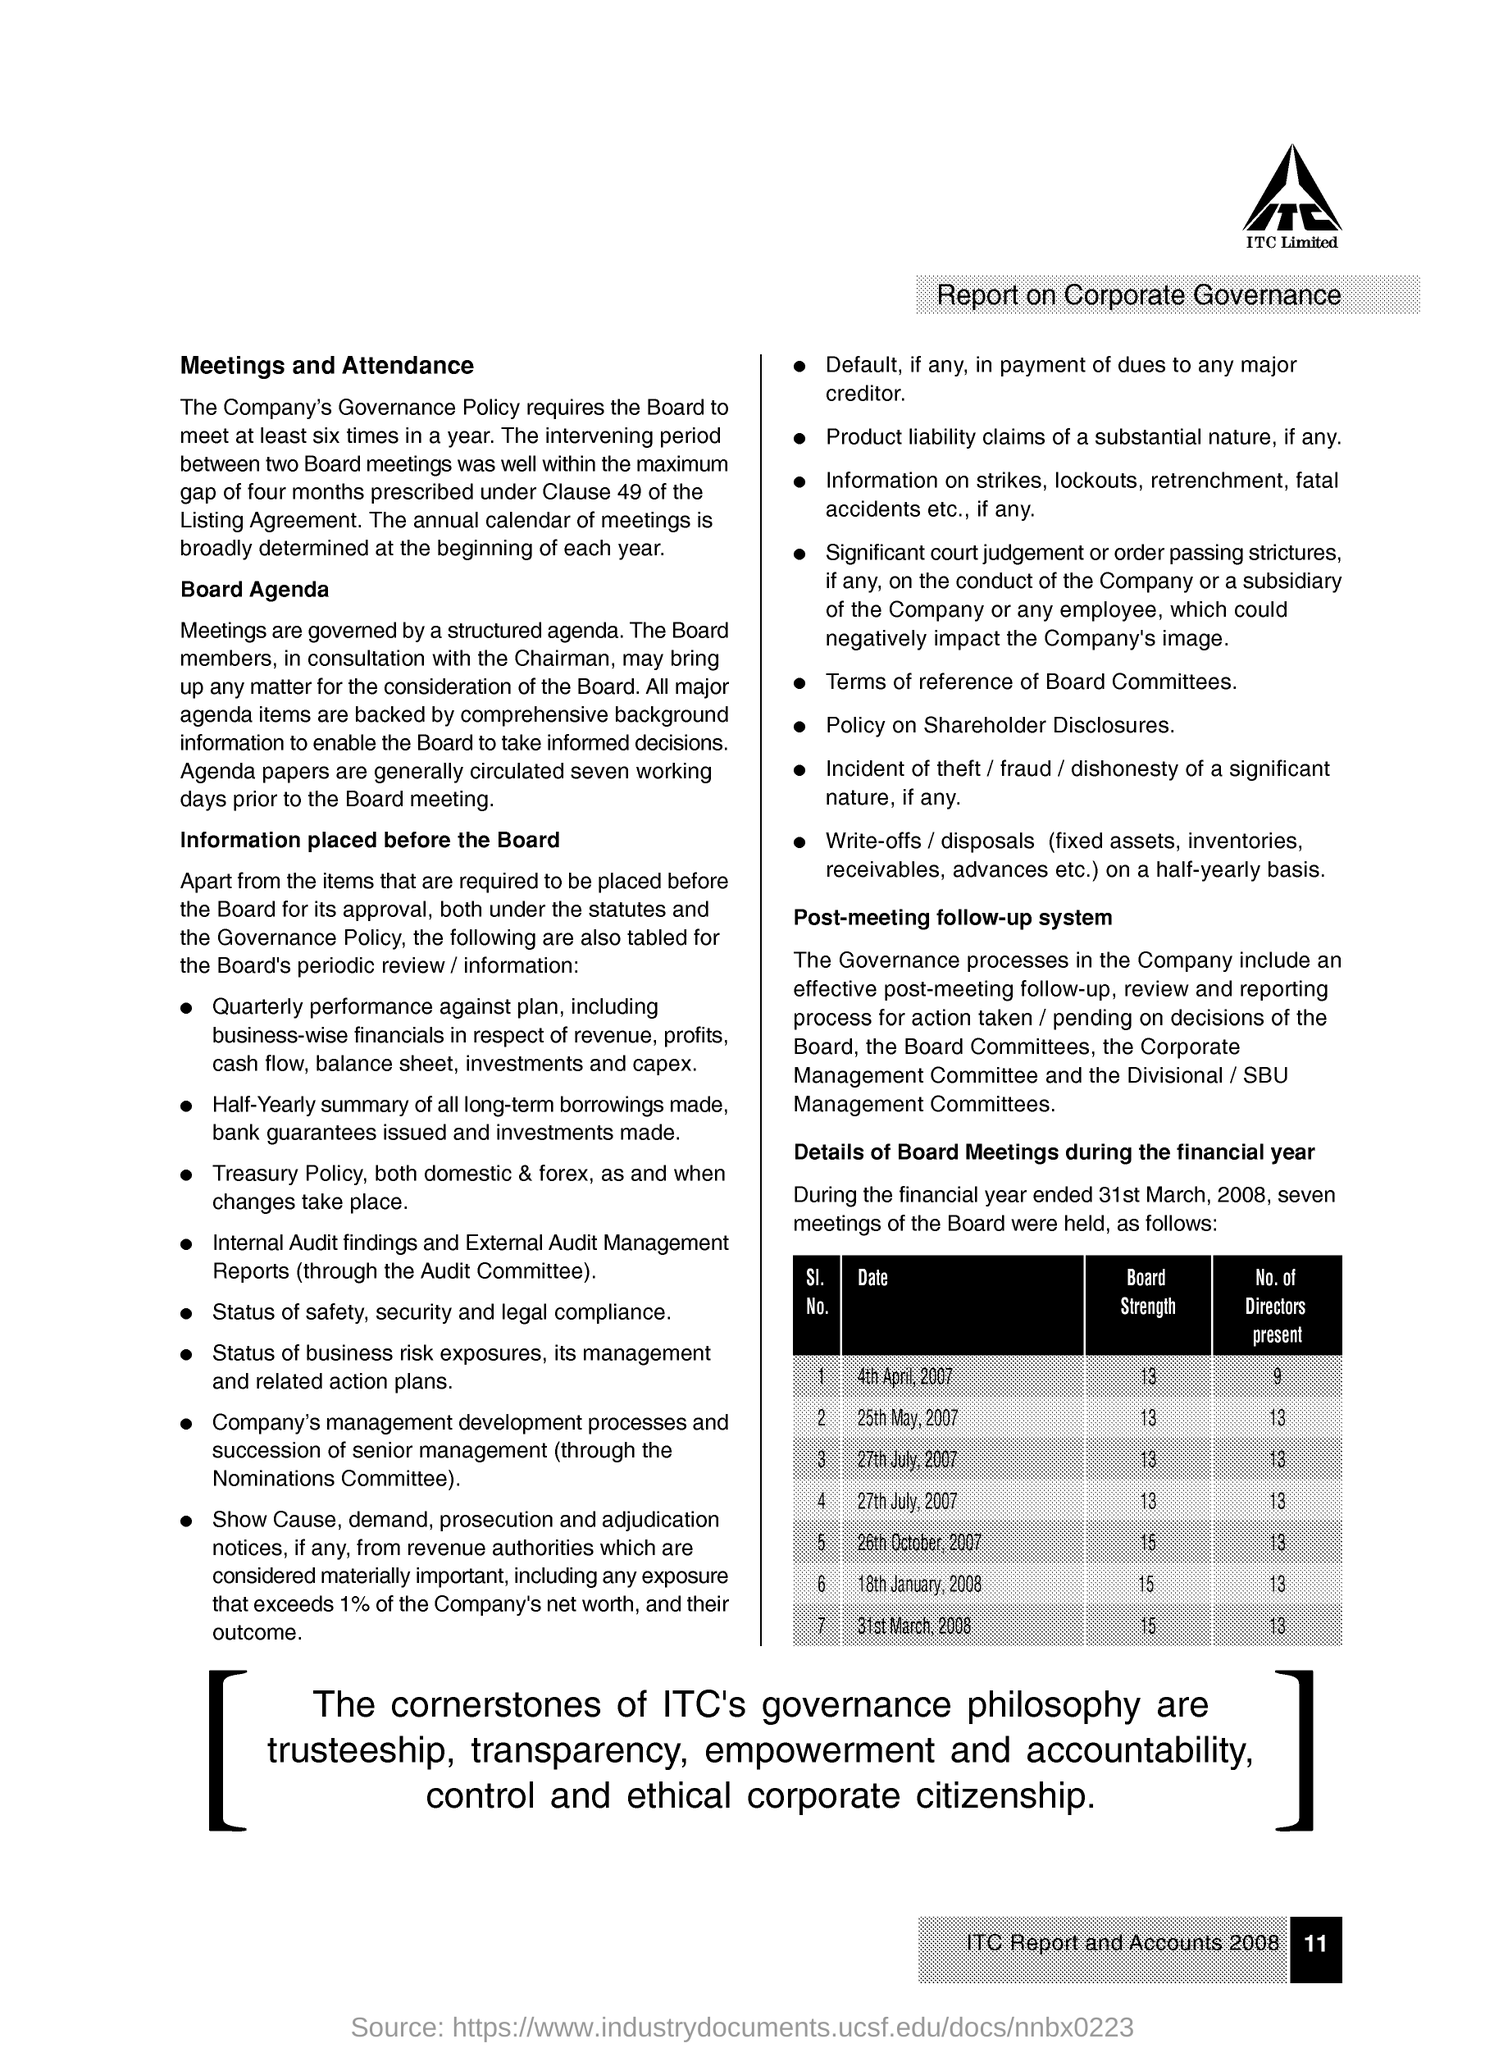Draw attention to some important aspects in this diagram. On April 4th, 2007, there were 9 directors present. The board strength for the date of April 4, 2007 was 13. The board strength on March 31, 2008 was 15. On May 25, 2007, there were 13 directors present. On January 18th, 2008, the Board Strength was 15. 